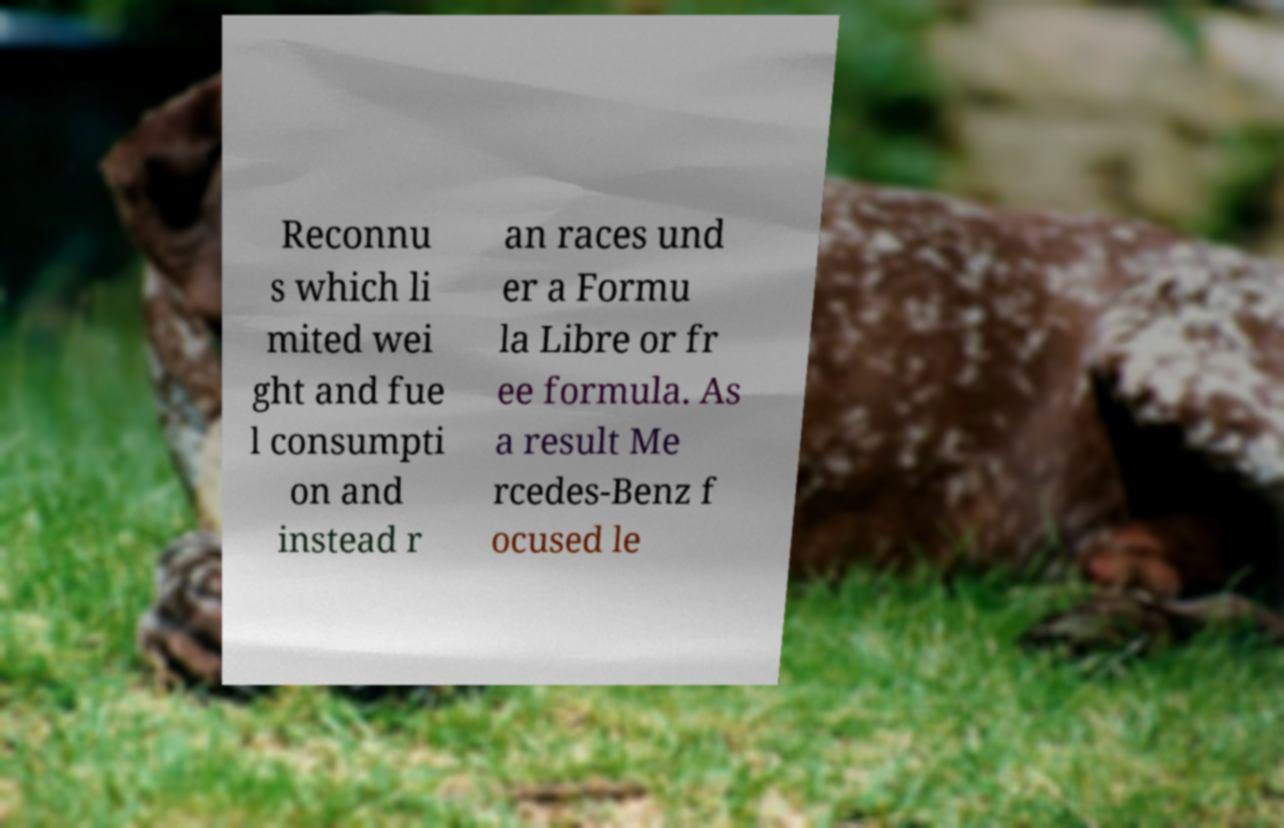For documentation purposes, I need the text within this image transcribed. Could you provide that? Reconnu s which li mited wei ght and fue l consumpti on and instead r an races und er a Formu la Libre or fr ee formula. As a result Me rcedes-Benz f ocused le 